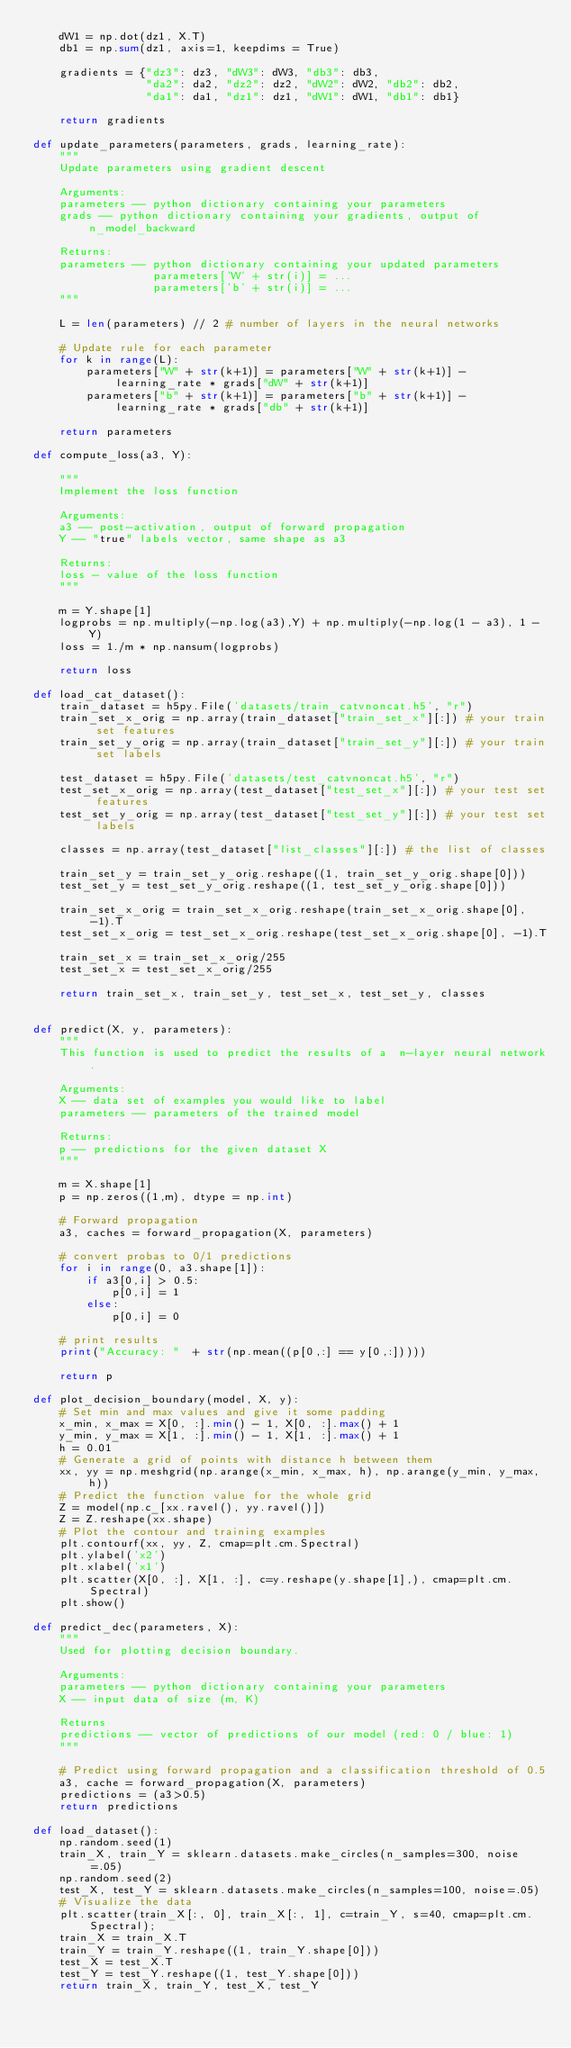Convert code to text. <code><loc_0><loc_0><loc_500><loc_500><_Python_>    dW1 = np.dot(dz1, X.T)
    db1 = np.sum(dz1, axis=1, keepdims = True)
    
    gradients = {"dz3": dz3, "dW3": dW3, "db3": db3,
                 "da2": da2, "dz2": dz2, "dW2": dW2, "db2": db2,
                 "da1": da1, "dz1": dz1, "dW1": dW1, "db1": db1}
    
    return gradients

def update_parameters(parameters, grads, learning_rate):
    """
    Update parameters using gradient descent
    
    Arguments:
    parameters -- python dictionary containing your parameters 
    grads -- python dictionary containing your gradients, output of n_model_backward
    
    Returns:
    parameters -- python dictionary containing your updated parameters 
                  parameters['W' + str(i)] = ... 
                  parameters['b' + str(i)] = ...
    """
    
    L = len(parameters) // 2 # number of layers in the neural networks

    # Update rule for each parameter
    for k in range(L):
        parameters["W" + str(k+1)] = parameters["W" + str(k+1)] - learning_rate * grads["dW" + str(k+1)]
        parameters["b" + str(k+1)] = parameters["b" + str(k+1)] - learning_rate * grads["db" + str(k+1)]
        
    return parameters

def compute_loss(a3, Y):
    
    """
    Implement the loss function
    
    Arguments:
    a3 -- post-activation, output of forward propagation
    Y -- "true" labels vector, same shape as a3
    
    Returns:
    loss - value of the loss function
    """
    
    m = Y.shape[1]
    logprobs = np.multiply(-np.log(a3),Y) + np.multiply(-np.log(1 - a3), 1 - Y)
    loss = 1./m * np.nansum(logprobs)
    
    return loss

def load_cat_dataset():
    train_dataset = h5py.File('datasets/train_catvnoncat.h5', "r")
    train_set_x_orig = np.array(train_dataset["train_set_x"][:]) # your train set features
    train_set_y_orig = np.array(train_dataset["train_set_y"][:]) # your train set labels

    test_dataset = h5py.File('datasets/test_catvnoncat.h5', "r")
    test_set_x_orig = np.array(test_dataset["test_set_x"][:]) # your test set features
    test_set_y_orig = np.array(test_dataset["test_set_y"][:]) # your test set labels

    classes = np.array(test_dataset["list_classes"][:]) # the list of classes
    
    train_set_y = train_set_y_orig.reshape((1, train_set_y_orig.shape[0]))
    test_set_y = test_set_y_orig.reshape((1, test_set_y_orig.shape[0]))
    
    train_set_x_orig = train_set_x_orig.reshape(train_set_x_orig.shape[0], -1).T
    test_set_x_orig = test_set_x_orig.reshape(test_set_x_orig.shape[0], -1).T
    
    train_set_x = train_set_x_orig/255
    test_set_x = test_set_x_orig/255

    return train_set_x, train_set_y, test_set_x, test_set_y, classes


def predict(X, y, parameters):
    """
    This function is used to predict the results of a  n-layer neural network.
    
    Arguments:
    X -- data set of examples you would like to label
    parameters -- parameters of the trained model
    
    Returns:
    p -- predictions for the given dataset X
    """
    
    m = X.shape[1]
    p = np.zeros((1,m), dtype = np.int)
    
    # Forward propagation
    a3, caches = forward_propagation(X, parameters)
    
    # convert probas to 0/1 predictions
    for i in range(0, a3.shape[1]):
        if a3[0,i] > 0.5:
            p[0,i] = 1
        else:
            p[0,i] = 0

    # print results
    print("Accuracy: "  + str(np.mean((p[0,:] == y[0,:]))))
    
    return p

def plot_decision_boundary(model, X, y):
    # Set min and max values and give it some padding
    x_min, x_max = X[0, :].min() - 1, X[0, :].max() + 1
    y_min, y_max = X[1, :].min() - 1, X[1, :].max() + 1
    h = 0.01
    # Generate a grid of points with distance h between them
    xx, yy = np.meshgrid(np.arange(x_min, x_max, h), np.arange(y_min, y_max, h))
    # Predict the function value for the whole grid
    Z = model(np.c_[xx.ravel(), yy.ravel()])
    Z = Z.reshape(xx.shape)
    # Plot the contour and training examples
    plt.contourf(xx, yy, Z, cmap=plt.cm.Spectral)
    plt.ylabel('x2')
    plt.xlabel('x1')
    plt.scatter(X[0, :], X[1, :], c=y.reshape(y.shape[1],), cmap=plt.cm.Spectral)
    plt.show()
    
def predict_dec(parameters, X):
    """
    Used for plotting decision boundary.
    
    Arguments:
    parameters -- python dictionary containing your parameters 
    X -- input data of size (m, K)
    
    Returns
    predictions -- vector of predictions of our model (red: 0 / blue: 1)
    """
    
    # Predict using forward propagation and a classification threshold of 0.5
    a3, cache = forward_propagation(X, parameters)
    predictions = (a3>0.5)
    return predictions

def load_dataset():
    np.random.seed(1)
    train_X, train_Y = sklearn.datasets.make_circles(n_samples=300, noise=.05)
    np.random.seed(2)
    test_X, test_Y = sklearn.datasets.make_circles(n_samples=100, noise=.05)
    # Visualize the data
    plt.scatter(train_X[:, 0], train_X[:, 1], c=train_Y, s=40, cmap=plt.cm.Spectral);
    train_X = train_X.T
    train_Y = train_Y.reshape((1, train_Y.shape[0]))
    test_X = test_X.T
    test_Y = test_Y.reshape((1, test_Y.shape[0]))
    return train_X, train_Y, test_X, test_Y</code> 